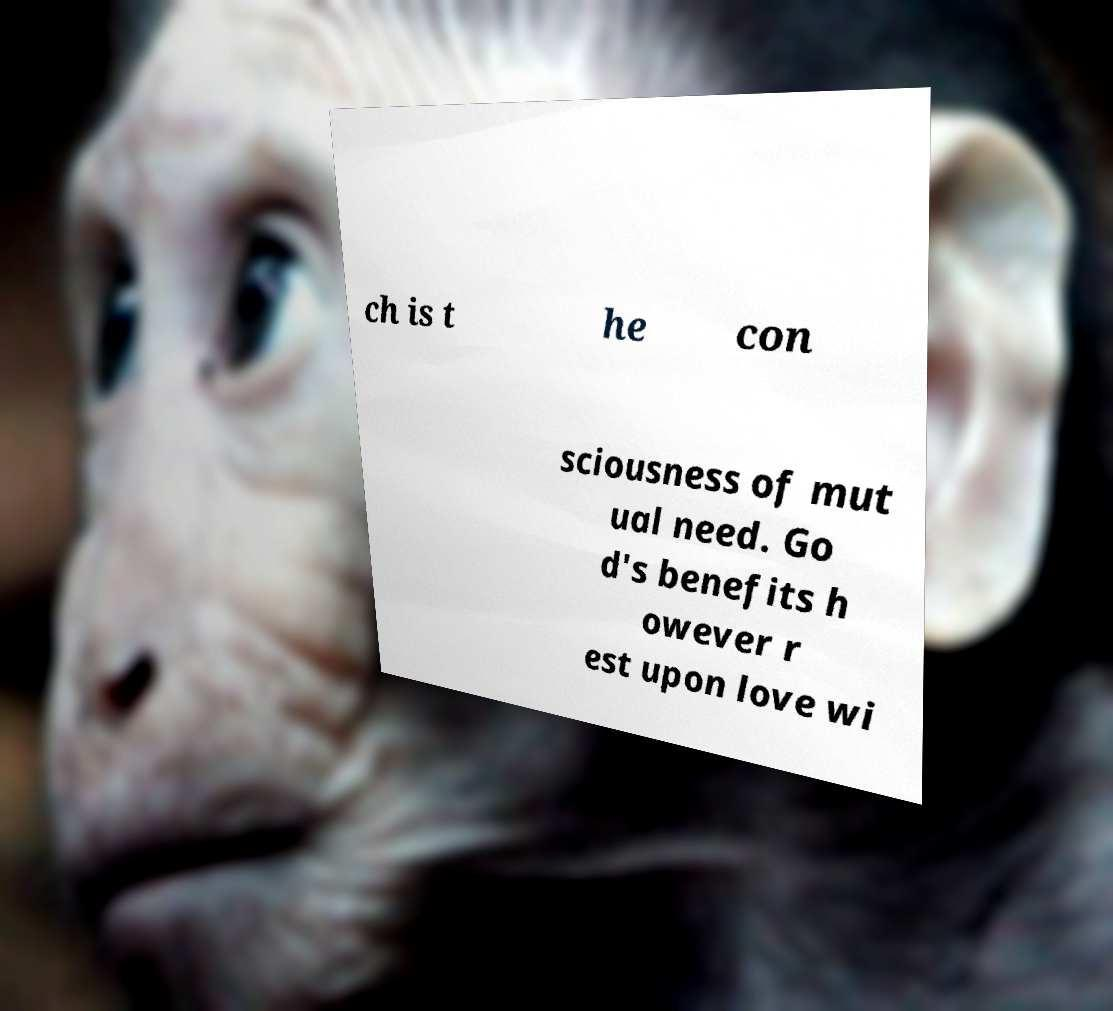Can you read and provide the text displayed in the image?This photo seems to have some interesting text. Can you extract and type it out for me? ch is t he con sciousness of mut ual need. Go d's benefits h owever r est upon love wi 